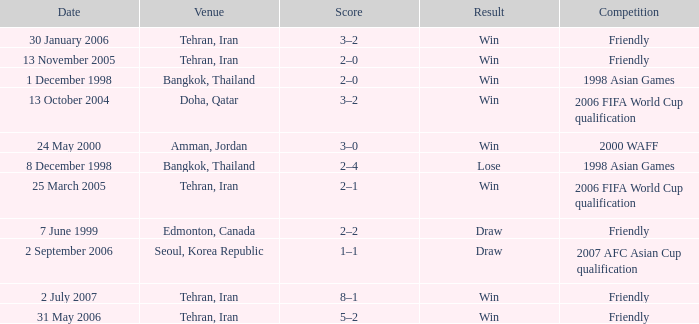What was the competition on 7 June 1999? Friendly. 